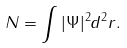Convert formula to latex. <formula><loc_0><loc_0><loc_500><loc_500>N = \int | \Psi | ^ { 2 } d ^ { 2 } r .</formula> 